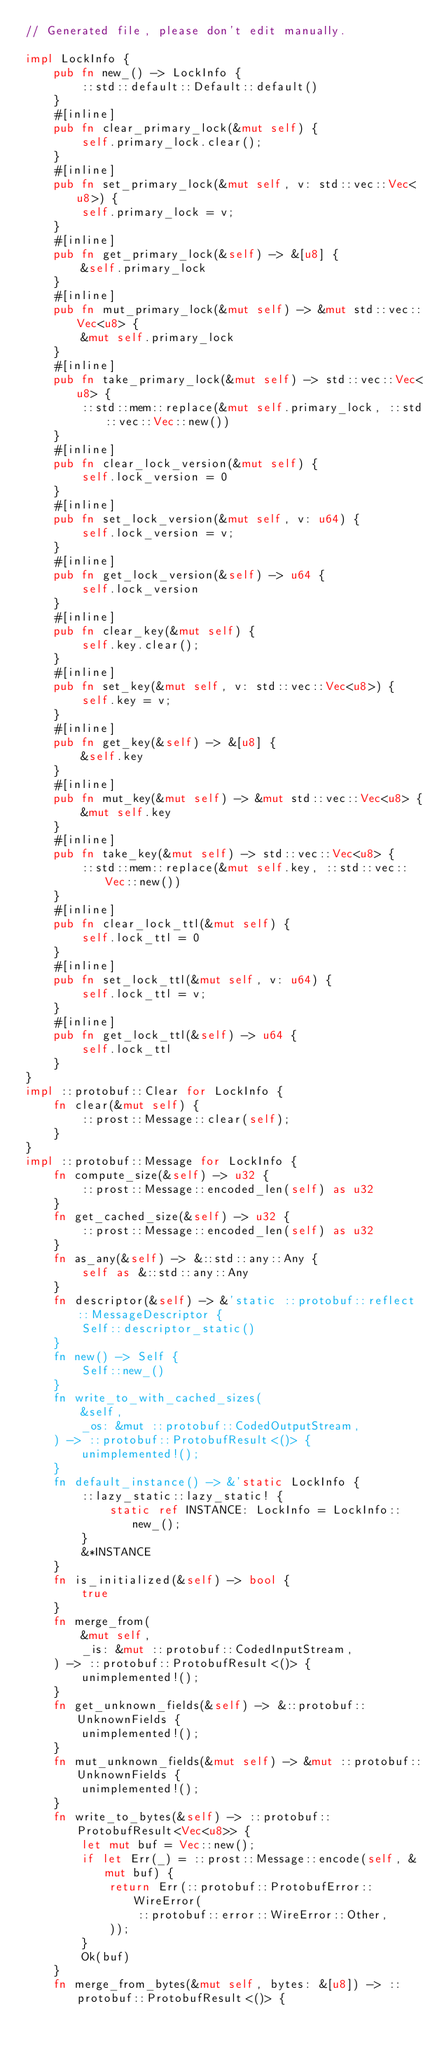Convert code to text. <code><loc_0><loc_0><loc_500><loc_500><_Rust_>// Generated file, please don't edit manually.

impl LockInfo {
    pub fn new_() -> LockInfo {
        ::std::default::Default::default()
    }
    #[inline]
    pub fn clear_primary_lock(&mut self) {
        self.primary_lock.clear();
    }
    #[inline]
    pub fn set_primary_lock(&mut self, v: std::vec::Vec<u8>) {
        self.primary_lock = v;
    }
    #[inline]
    pub fn get_primary_lock(&self) -> &[u8] {
        &self.primary_lock
    }
    #[inline]
    pub fn mut_primary_lock(&mut self) -> &mut std::vec::Vec<u8> {
        &mut self.primary_lock
    }
    #[inline]
    pub fn take_primary_lock(&mut self) -> std::vec::Vec<u8> {
        ::std::mem::replace(&mut self.primary_lock, ::std::vec::Vec::new())
    }
    #[inline]
    pub fn clear_lock_version(&mut self) {
        self.lock_version = 0
    }
    #[inline]
    pub fn set_lock_version(&mut self, v: u64) {
        self.lock_version = v;
    }
    #[inline]
    pub fn get_lock_version(&self) -> u64 {
        self.lock_version
    }
    #[inline]
    pub fn clear_key(&mut self) {
        self.key.clear();
    }
    #[inline]
    pub fn set_key(&mut self, v: std::vec::Vec<u8>) {
        self.key = v;
    }
    #[inline]
    pub fn get_key(&self) -> &[u8] {
        &self.key
    }
    #[inline]
    pub fn mut_key(&mut self) -> &mut std::vec::Vec<u8> {
        &mut self.key
    }
    #[inline]
    pub fn take_key(&mut self) -> std::vec::Vec<u8> {
        ::std::mem::replace(&mut self.key, ::std::vec::Vec::new())
    }
    #[inline]
    pub fn clear_lock_ttl(&mut self) {
        self.lock_ttl = 0
    }
    #[inline]
    pub fn set_lock_ttl(&mut self, v: u64) {
        self.lock_ttl = v;
    }
    #[inline]
    pub fn get_lock_ttl(&self) -> u64 {
        self.lock_ttl
    }
}
impl ::protobuf::Clear for LockInfo {
    fn clear(&mut self) {
        ::prost::Message::clear(self);
    }
}
impl ::protobuf::Message for LockInfo {
    fn compute_size(&self) -> u32 {
        ::prost::Message::encoded_len(self) as u32
    }
    fn get_cached_size(&self) -> u32 {
        ::prost::Message::encoded_len(self) as u32
    }
    fn as_any(&self) -> &::std::any::Any {
        self as &::std::any::Any
    }
    fn descriptor(&self) -> &'static ::protobuf::reflect::MessageDescriptor {
        Self::descriptor_static()
    }
    fn new() -> Self {
        Self::new_()
    }
    fn write_to_with_cached_sizes(
        &self,
        _os: &mut ::protobuf::CodedOutputStream,
    ) -> ::protobuf::ProtobufResult<()> {
        unimplemented!();
    }
    fn default_instance() -> &'static LockInfo {
        ::lazy_static::lazy_static! {
            static ref INSTANCE: LockInfo = LockInfo::new_();
        }
        &*INSTANCE
    }
    fn is_initialized(&self) -> bool {
        true
    }
    fn merge_from(
        &mut self,
        _is: &mut ::protobuf::CodedInputStream,
    ) -> ::protobuf::ProtobufResult<()> {
        unimplemented!();
    }
    fn get_unknown_fields(&self) -> &::protobuf::UnknownFields {
        unimplemented!();
    }
    fn mut_unknown_fields(&mut self) -> &mut ::protobuf::UnknownFields {
        unimplemented!();
    }
    fn write_to_bytes(&self) -> ::protobuf::ProtobufResult<Vec<u8>> {
        let mut buf = Vec::new();
        if let Err(_) = ::prost::Message::encode(self, &mut buf) {
            return Err(::protobuf::ProtobufError::WireError(
                ::protobuf::error::WireError::Other,
            ));
        }
        Ok(buf)
    }
    fn merge_from_bytes(&mut self, bytes: &[u8]) -> ::protobuf::ProtobufResult<()> {</code> 